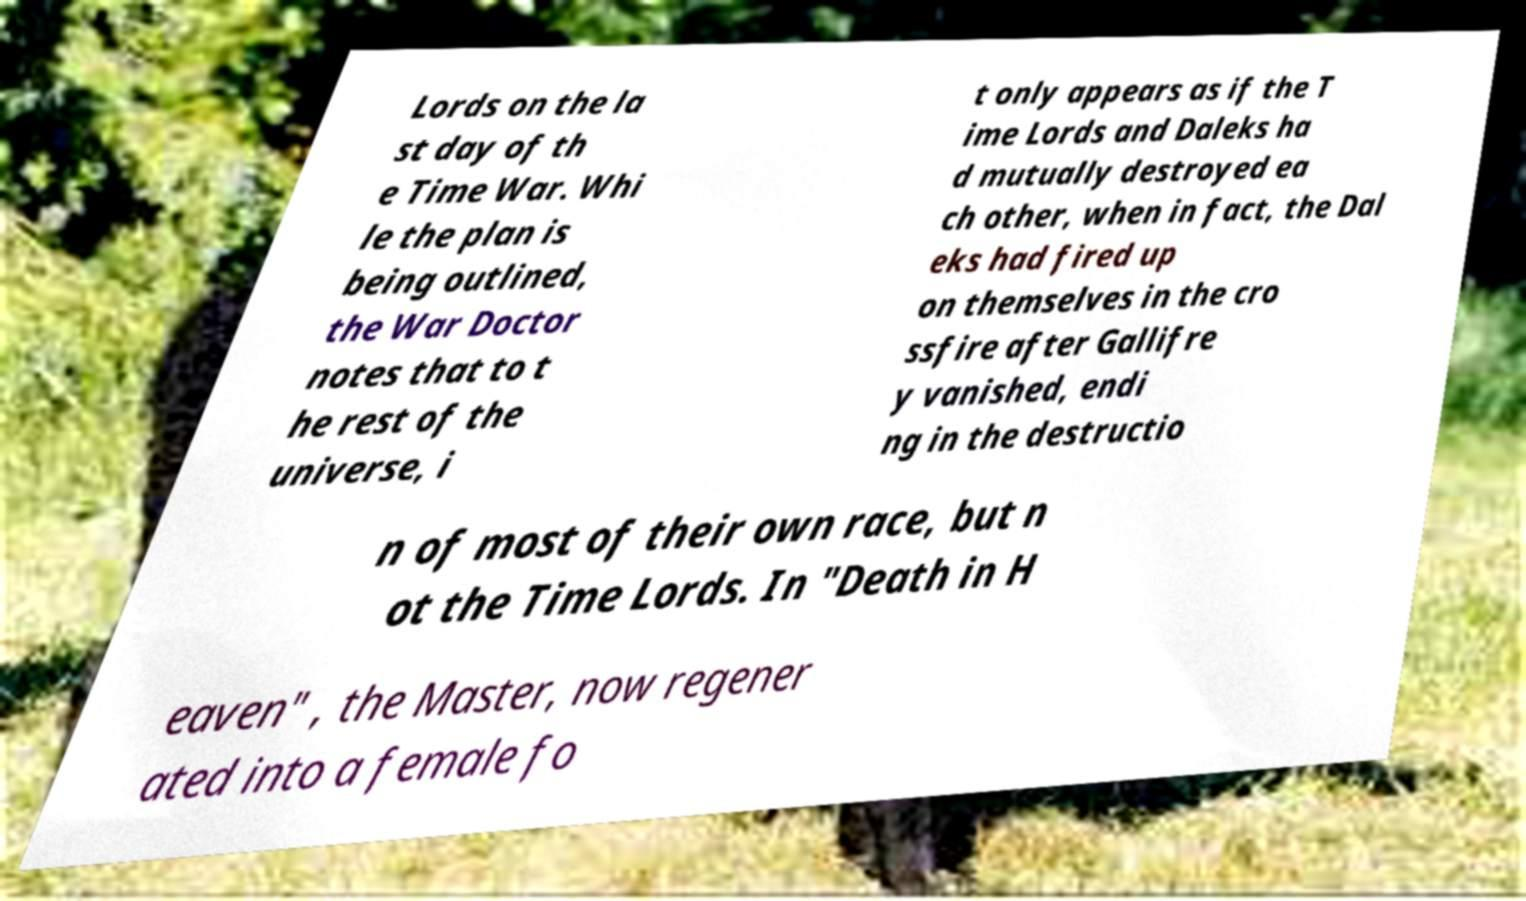Can you accurately transcribe the text from the provided image for me? Lords on the la st day of th e Time War. Whi le the plan is being outlined, the War Doctor notes that to t he rest of the universe, i t only appears as if the T ime Lords and Daleks ha d mutually destroyed ea ch other, when in fact, the Dal eks had fired up on themselves in the cro ssfire after Gallifre y vanished, endi ng in the destructio n of most of their own race, but n ot the Time Lords. In "Death in H eaven" , the Master, now regener ated into a female fo 